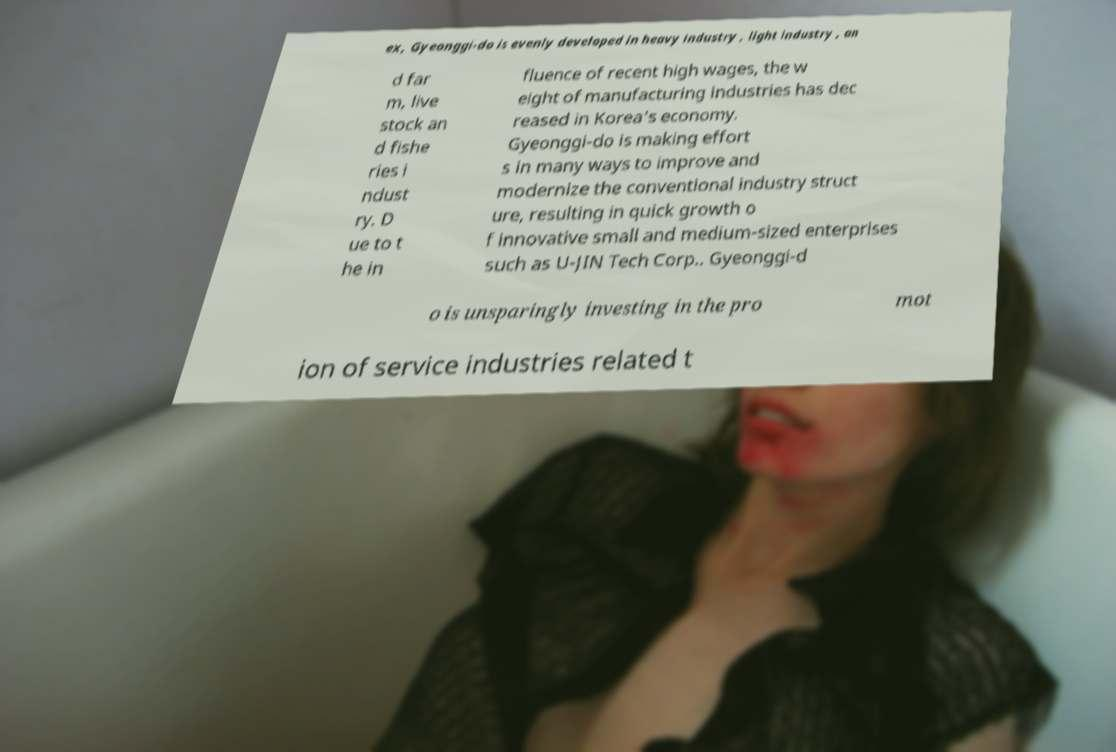Please identify and transcribe the text found in this image. ex, Gyeonggi-do is evenly developed in heavy industry , light industry , an d far m, live stock an d fishe ries i ndust ry. D ue to t he in fluence of recent high wages, the w eight of manufacturing industries has dec reased in Korea's economy. Gyeonggi-do is making effort s in many ways to improve and modernize the conventional industry struct ure, resulting in quick growth o f innovative small and medium-sized enterprises such as U-JIN Tech Corp.. Gyeonggi-d o is unsparingly investing in the pro mot ion of service industries related t 